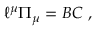Convert formula to latex. <formula><loc_0><loc_0><loc_500><loc_500>{ \ell } ^ { \mu } { \mathit \Pi } _ { \mu } = { B } { C } \ ,</formula> 